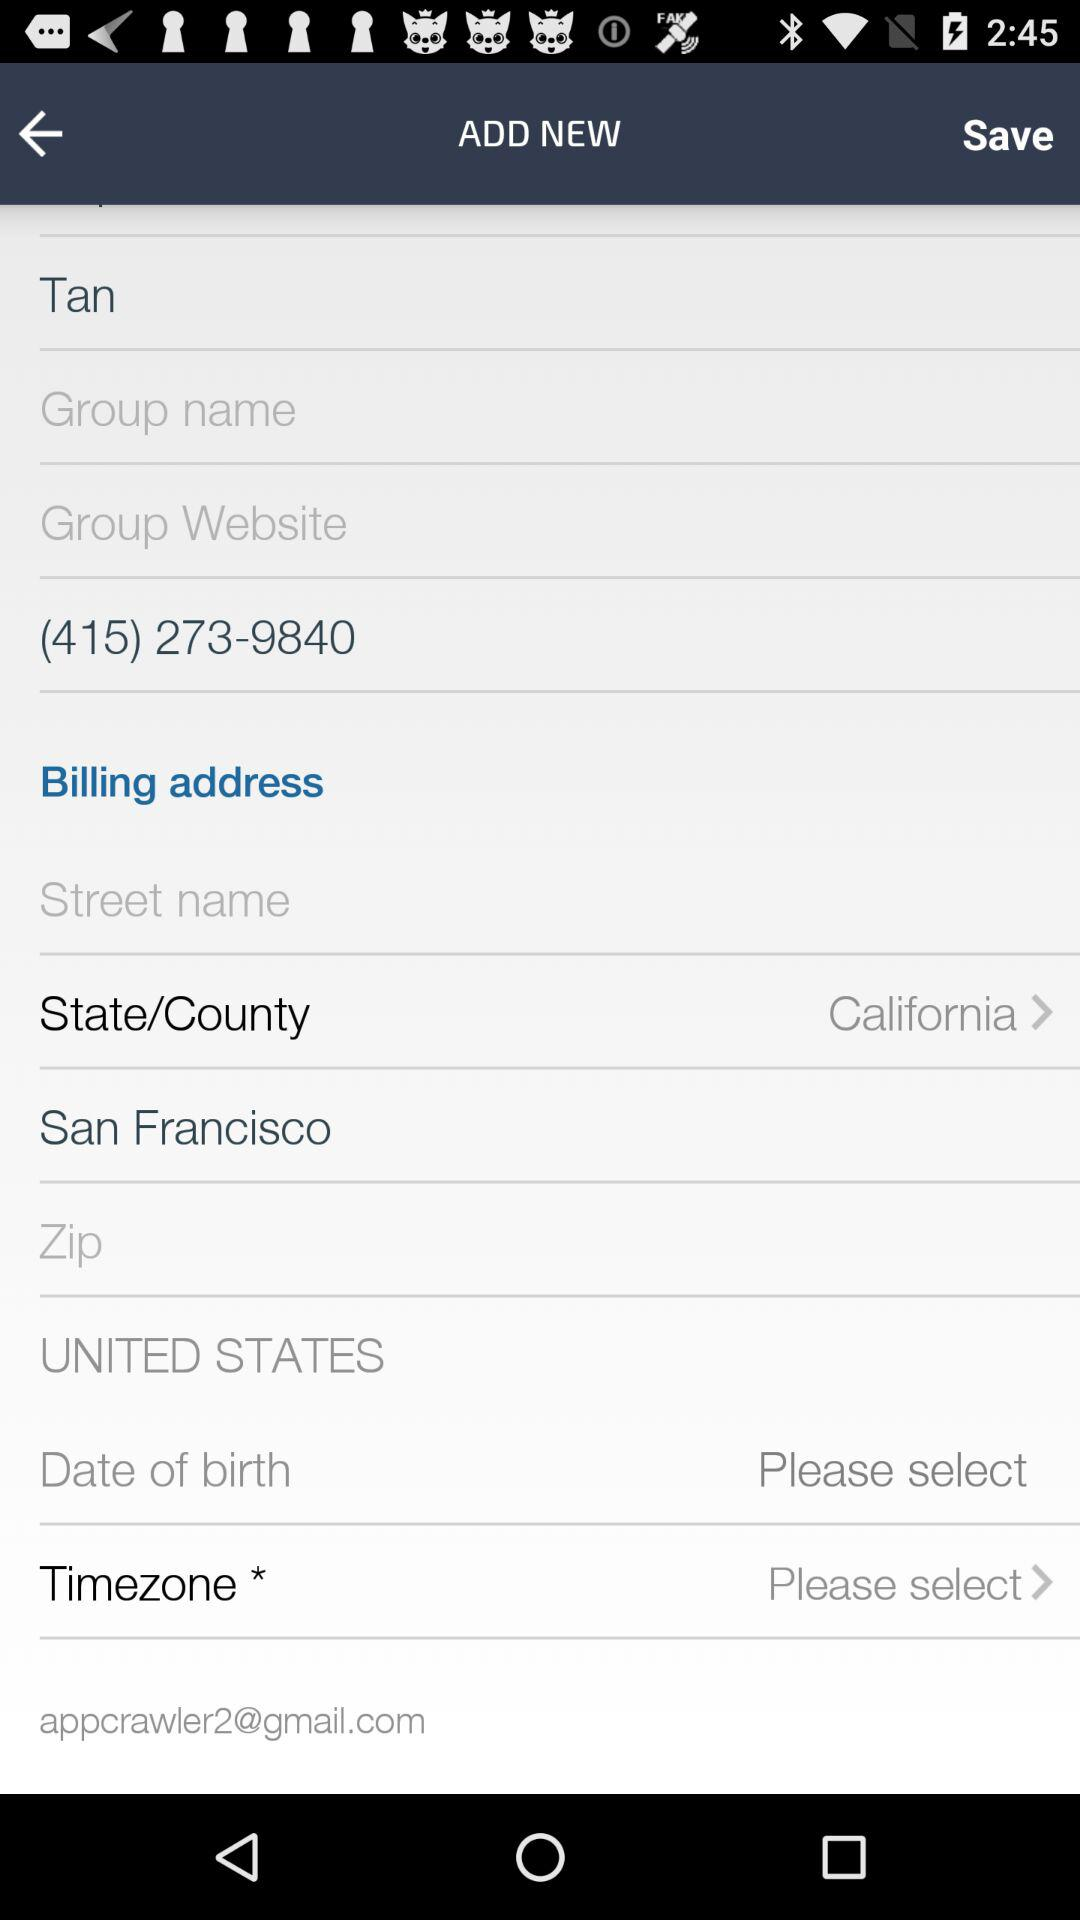What is the email address? The email address is appcrawler2@gmail.com. 